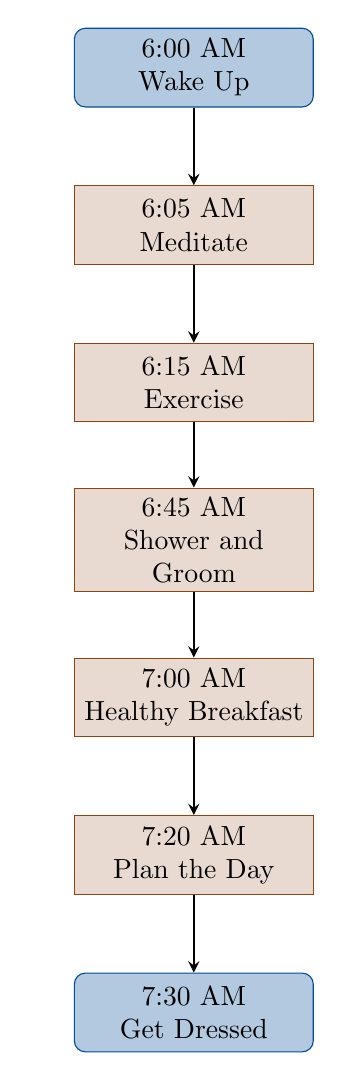What is the first activity in the morning routine? The first activity listed in the diagram is “Wake Up,” which occurs at 6:00 AM.
Answer: Wake Up How long does the meditation last? The meditation activity occurs from 6:05 AM to 6:15 AM, lasting for a total of 10 minutes.
Answer: 10 minutes What is the activity scheduled for 7:00 AM? According to the diagram, the activity scheduled at 7:00 AM is “Healthy Breakfast.”
Answer: Healthy Breakfast What is the last activity in the morning routine? The diagram indicates that the last activity is “Get Dressed,” which takes place at 7:30 AM.
Answer: Get Dressed How many activities are listed in the morning routine? The diagram details a total of 7 activities, starting from "Wake Up" and ending with "Get Dressed."
Answer: 7 Which activities are scheduled before taking a shower? The activities before “Shower and Groom” (scheduled for 6:45 AM) are “Wake Up,” “Meditate,” and “Exercise.”
Answer: Wake Up, Meditate, Exercise What is the time interval between exercising and having breakfast? The exercise activity ends at 6:45 AM, and breakfast starts at 7:00 AM, resulting in a 15-minute interval.
Answer: 15 minutes Which two activities are closely related in terms of readiness for the day? “Plan the Day” at 7:20 AM and “Get Dressed” at 7:30 AM are closely related, as planning and dressing set the tone for a productive day.
Answer: Plan the Day, Get Dressed What is the activity immediately following meditation? The activity immediately following “Meditate” is “Exercise,” which starts at 6:15 AM.
Answer: Exercise 